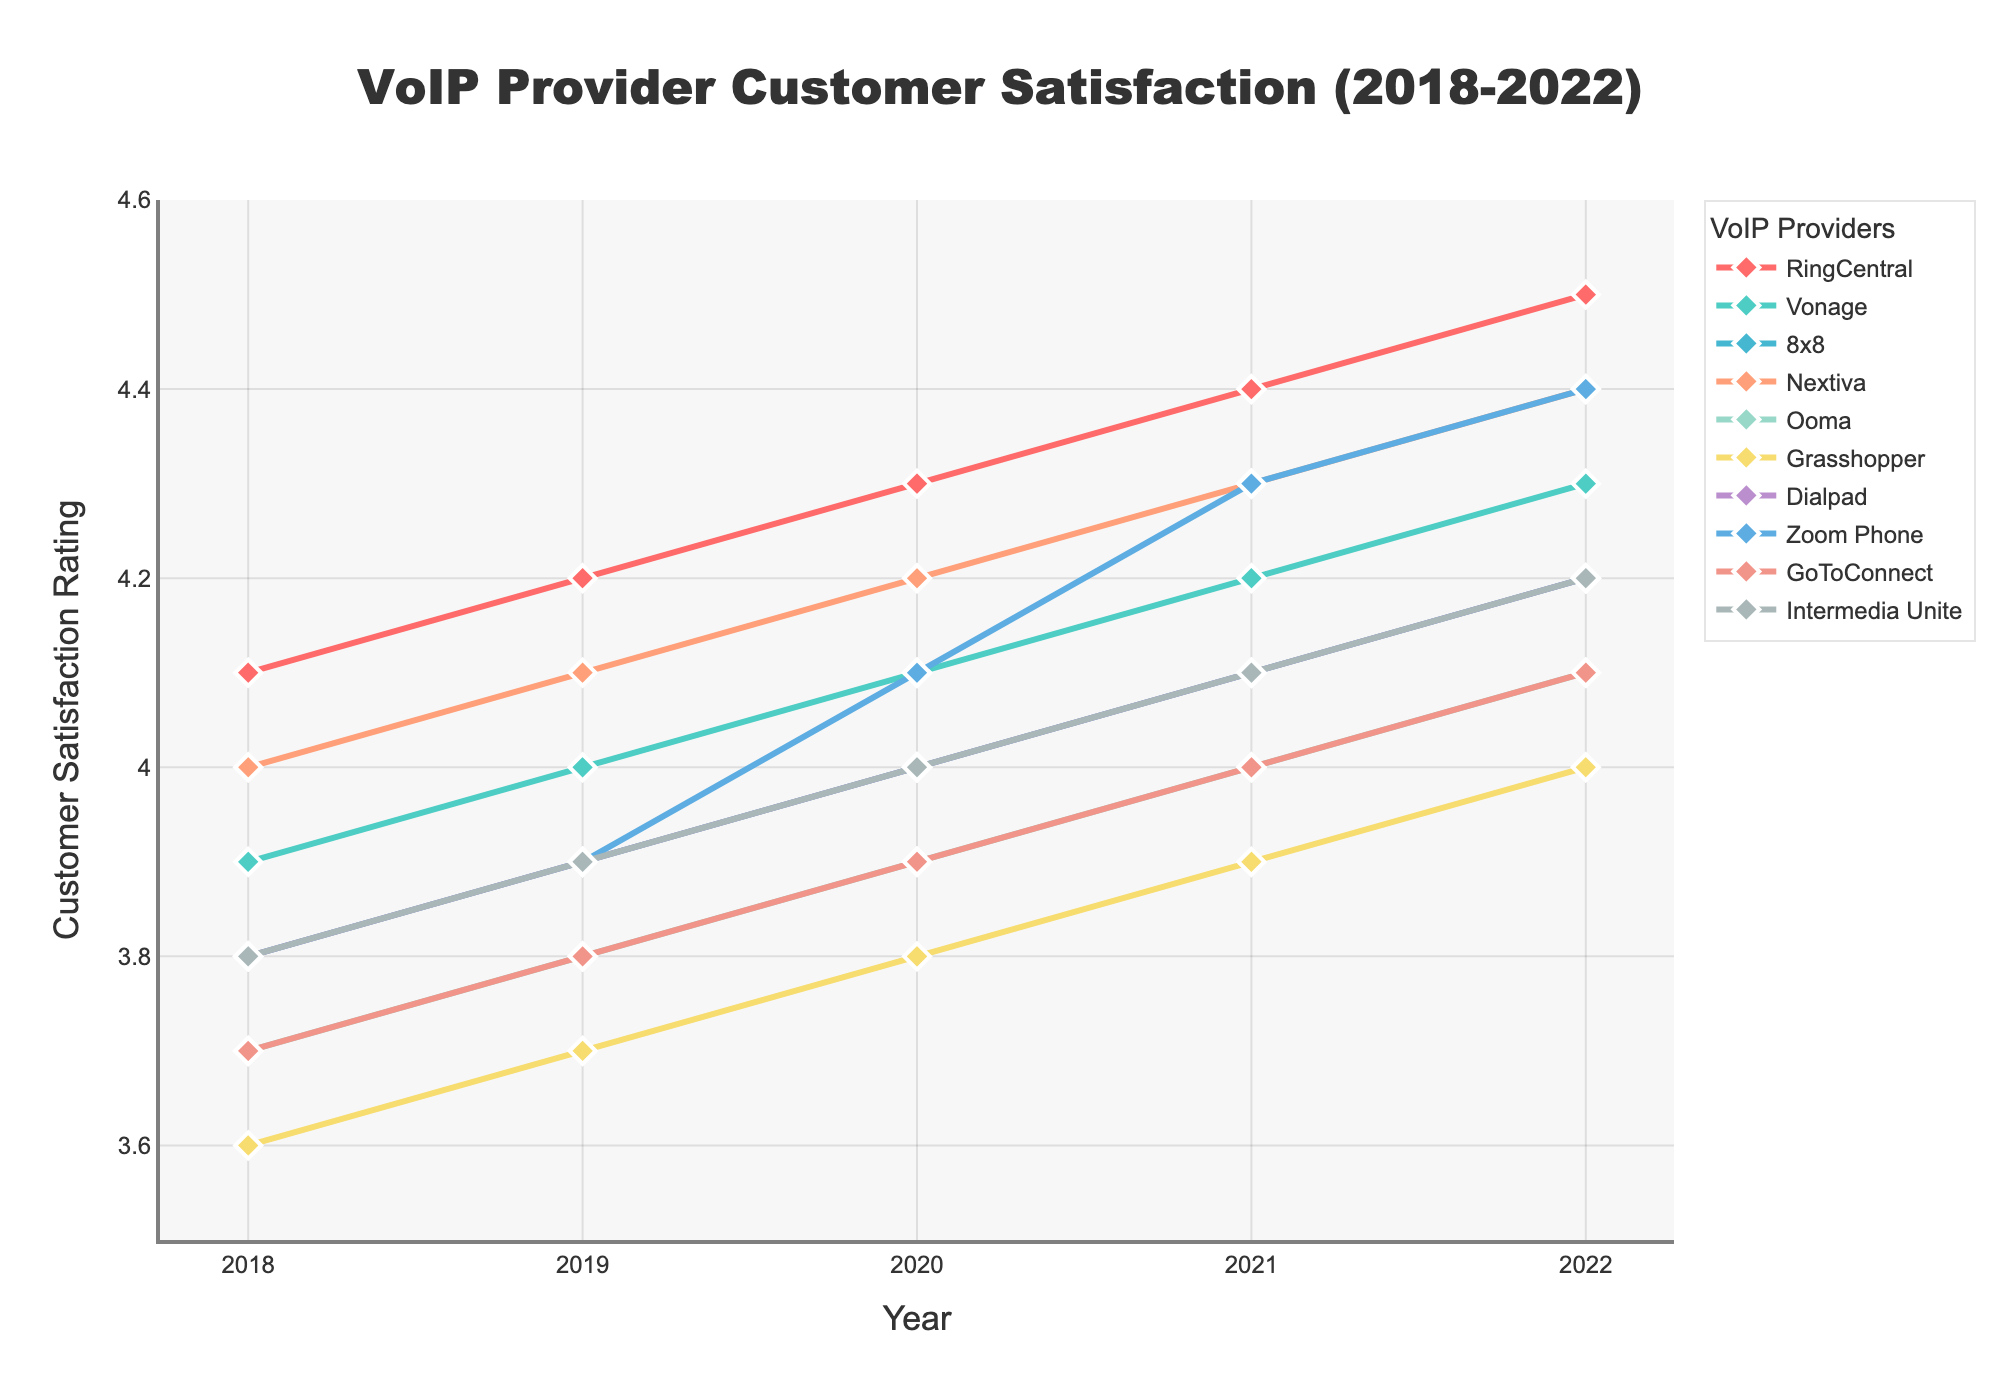Which VoIP provider had the highest customer satisfaction rating in 2022? By looking at the final year (2022) on the x-axis, find the provider with the highest y-value. RingCentral has the highest rating of 4.5 in 2022.
Answer: RingCentral How did Zoom Phone's customer satisfaction rating change from 2020 to 2021? Locate Zoom Phone's rating in 2020 and 2021, then subtract the 2020 value from the 2021 value, which is 4.3 - 4.1.
Answer: Increased by 0.2 Which VoIP provider had the most consistent increase in customer satisfaction ratings over the 5 years? Check the ratings over the years for each provider and look for a steady, incremental rise. RingCentral's ratings increased consistently from 4.1 in 2018 to 4.5 in 2022.
Answer: RingCentral Between Nextiva and 8x8, which had a higher average customer satisfaction rating over the 5 years? Calculate the average rating for both providers over the 5 years. Nextiva: (4.0+4.1+4.2+4.3+4.4)/5 = 4.2; 8x8: (3.8+3.9+4.0+4.1+4.2)/5 = 4.0.
Answer: Nextiva Which provider showed the biggest single-year increase in any year? Track the differences year-over-year for each provider, and find the largest increase. Zoom Phone had the biggest single-year increase from 2020 (4.1) to 2021 (4.3), resulting in an increase of 0.2.
Answer: Zoom Phone What was the total increase in customer satisfaction for Dialpad from 2018 to 2022? Subtract Dialpad's rating in 2018 from its rating in 2022. The change is 4.2 - 3.8.
Answer: 0.4 Did any VoIP provider experience a decline in customer satisfaction at any time between 2018-2022? Observe the ratings for each provider for any year-over-year decreases. All providers show consistent increases each year, so none declined.
Answer: No Which provider had the lowest customer satisfaction rating in 2018? By looking at the year 2018 on the x-axis, identify the provider with the lowest y-value. Grasshopper had the lowest rating of 3.6 in 2018.
Answer: Grasshopper In 2020, which provider had the highest customer satisfaction rating? Look at the ratings for all providers in the year 2020 and find the highest value. RingCentral had the highest rating of 4.3.
Answer: RingCentral 